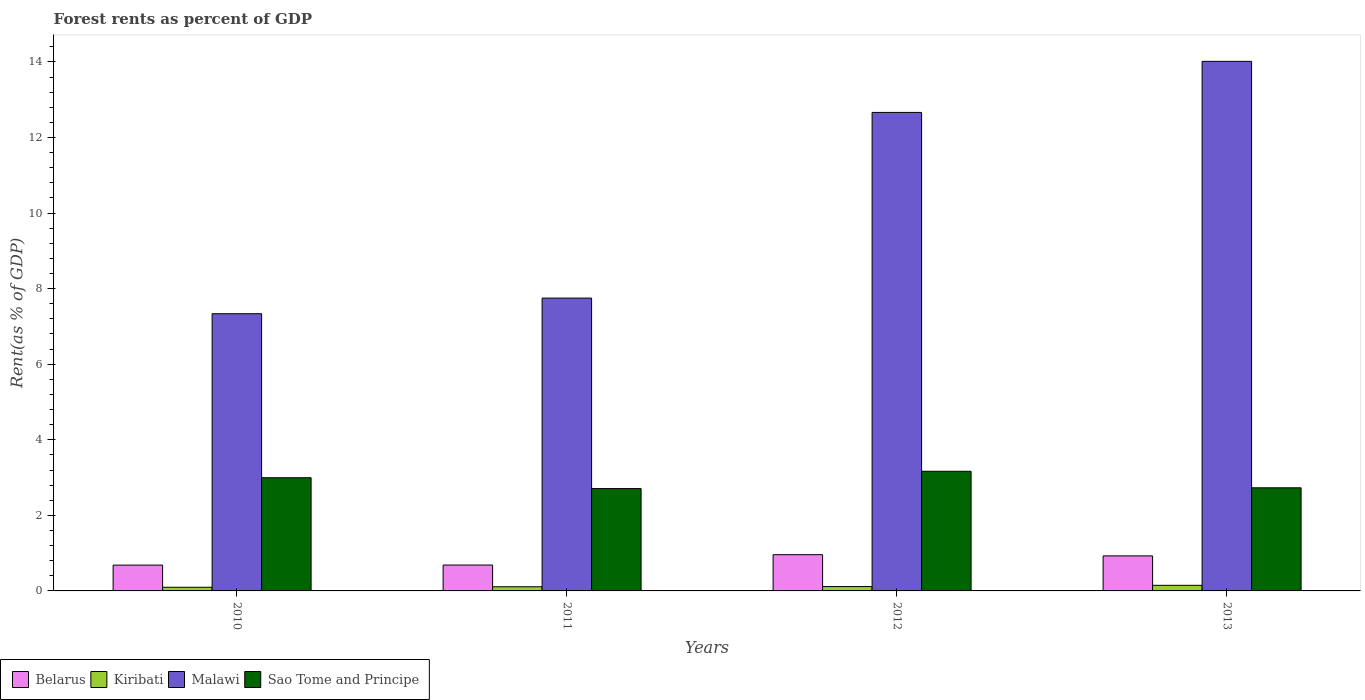How many different coloured bars are there?
Provide a succinct answer. 4. Are the number of bars per tick equal to the number of legend labels?
Provide a succinct answer. Yes. Are the number of bars on each tick of the X-axis equal?
Ensure brevity in your answer.  Yes. How many bars are there on the 1st tick from the left?
Keep it short and to the point. 4. How many bars are there on the 2nd tick from the right?
Offer a very short reply. 4. What is the label of the 3rd group of bars from the left?
Offer a terse response. 2012. What is the forest rent in Sao Tome and Principe in 2013?
Give a very brief answer. 2.73. Across all years, what is the maximum forest rent in Kiribati?
Your answer should be very brief. 0.15. Across all years, what is the minimum forest rent in Sao Tome and Principe?
Provide a short and direct response. 2.71. In which year was the forest rent in Malawi maximum?
Offer a very short reply. 2013. In which year was the forest rent in Malawi minimum?
Keep it short and to the point. 2010. What is the total forest rent in Kiribati in the graph?
Make the answer very short. 0.47. What is the difference between the forest rent in Kiribati in 2010 and that in 2011?
Provide a succinct answer. -0.01. What is the difference between the forest rent in Malawi in 2011 and the forest rent in Sao Tome and Principe in 2010?
Provide a succinct answer. 4.75. What is the average forest rent in Kiribati per year?
Keep it short and to the point. 0.12. In the year 2012, what is the difference between the forest rent in Belarus and forest rent in Kiribati?
Your answer should be very brief. 0.84. What is the ratio of the forest rent in Belarus in 2011 to that in 2013?
Give a very brief answer. 0.74. Is the forest rent in Malawi in 2010 less than that in 2013?
Ensure brevity in your answer.  Yes. What is the difference between the highest and the second highest forest rent in Kiribati?
Make the answer very short. 0.03. What is the difference between the highest and the lowest forest rent in Malawi?
Make the answer very short. 6.68. In how many years, is the forest rent in Malawi greater than the average forest rent in Malawi taken over all years?
Keep it short and to the point. 2. What does the 1st bar from the left in 2010 represents?
Ensure brevity in your answer.  Belarus. What does the 4th bar from the right in 2013 represents?
Offer a terse response. Belarus. Is it the case that in every year, the sum of the forest rent in Belarus and forest rent in Kiribati is greater than the forest rent in Malawi?
Your response must be concise. No. Does the graph contain grids?
Provide a short and direct response. No. How many legend labels are there?
Provide a succinct answer. 4. How are the legend labels stacked?
Give a very brief answer. Horizontal. What is the title of the graph?
Your answer should be compact. Forest rents as percent of GDP. What is the label or title of the Y-axis?
Provide a succinct answer. Rent(as % of GDP). What is the Rent(as % of GDP) of Belarus in 2010?
Make the answer very short. 0.68. What is the Rent(as % of GDP) in Kiribati in 2010?
Give a very brief answer. 0.1. What is the Rent(as % of GDP) in Malawi in 2010?
Ensure brevity in your answer.  7.34. What is the Rent(as % of GDP) of Sao Tome and Principe in 2010?
Your response must be concise. 3. What is the Rent(as % of GDP) in Belarus in 2011?
Make the answer very short. 0.69. What is the Rent(as % of GDP) in Kiribati in 2011?
Offer a terse response. 0.11. What is the Rent(as % of GDP) of Malawi in 2011?
Offer a terse response. 7.75. What is the Rent(as % of GDP) of Sao Tome and Principe in 2011?
Ensure brevity in your answer.  2.71. What is the Rent(as % of GDP) of Belarus in 2012?
Ensure brevity in your answer.  0.96. What is the Rent(as % of GDP) of Kiribati in 2012?
Give a very brief answer. 0.12. What is the Rent(as % of GDP) in Malawi in 2012?
Provide a succinct answer. 12.66. What is the Rent(as % of GDP) in Sao Tome and Principe in 2012?
Ensure brevity in your answer.  3.17. What is the Rent(as % of GDP) of Belarus in 2013?
Make the answer very short. 0.93. What is the Rent(as % of GDP) of Kiribati in 2013?
Offer a terse response. 0.15. What is the Rent(as % of GDP) of Malawi in 2013?
Offer a very short reply. 14.01. What is the Rent(as % of GDP) in Sao Tome and Principe in 2013?
Provide a succinct answer. 2.73. Across all years, what is the maximum Rent(as % of GDP) in Belarus?
Ensure brevity in your answer.  0.96. Across all years, what is the maximum Rent(as % of GDP) in Kiribati?
Offer a very short reply. 0.15. Across all years, what is the maximum Rent(as % of GDP) in Malawi?
Offer a very short reply. 14.01. Across all years, what is the maximum Rent(as % of GDP) of Sao Tome and Principe?
Keep it short and to the point. 3.17. Across all years, what is the minimum Rent(as % of GDP) in Belarus?
Make the answer very short. 0.68. Across all years, what is the minimum Rent(as % of GDP) of Kiribati?
Offer a very short reply. 0.1. Across all years, what is the minimum Rent(as % of GDP) of Malawi?
Give a very brief answer. 7.34. Across all years, what is the minimum Rent(as % of GDP) of Sao Tome and Principe?
Offer a very short reply. 2.71. What is the total Rent(as % of GDP) of Belarus in the graph?
Your answer should be very brief. 3.25. What is the total Rent(as % of GDP) of Kiribati in the graph?
Your answer should be compact. 0.47. What is the total Rent(as % of GDP) in Malawi in the graph?
Offer a very short reply. 41.76. What is the total Rent(as % of GDP) in Sao Tome and Principe in the graph?
Give a very brief answer. 11.6. What is the difference between the Rent(as % of GDP) in Belarus in 2010 and that in 2011?
Offer a very short reply. -0. What is the difference between the Rent(as % of GDP) in Kiribati in 2010 and that in 2011?
Offer a very short reply. -0.01. What is the difference between the Rent(as % of GDP) in Malawi in 2010 and that in 2011?
Make the answer very short. -0.41. What is the difference between the Rent(as % of GDP) in Sao Tome and Principe in 2010 and that in 2011?
Offer a very short reply. 0.29. What is the difference between the Rent(as % of GDP) in Belarus in 2010 and that in 2012?
Offer a terse response. -0.28. What is the difference between the Rent(as % of GDP) of Kiribati in 2010 and that in 2012?
Provide a succinct answer. -0.02. What is the difference between the Rent(as % of GDP) in Malawi in 2010 and that in 2012?
Your answer should be compact. -5.33. What is the difference between the Rent(as % of GDP) in Sao Tome and Principe in 2010 and that in 2012?
Give a very brief answer. -0.17. What is the difference between the Rent(as % of GDP) of Belarus in 2010 and that in 2013?
Ensure brevity in your answer.  -0.24. What is the difference between the Rent(as % of GDP) of Kiribati in 2010 and that in 2013?
Your answer should be very brief. -0.05. What is the difference between the Rent(as % of GDP) of Malawi in 2010 and that in 2013?
Your answer should be very brief. -6.68. What is the difference between the Rent(as % of GDP) in Sao Tome and Principe in 2010 and that in 2013?
Give a very brief answer. 0.27. What is the difference between the Rent(as % of GDP) of Belarus in 2011 and that in 2012?
Offer a terse response. -0.27. What is the difference between the Rent(as % of GDP) in Kiribati in 2011 and that in 2012?
Your answer should be very brief. -0.01. What is the difference between the Rent(as % of GDP) in Malawi in 2011 and that in 2012?
Your response must be concise. -4.91. What is the difference between the Rent(as % of GDP) of Sao Tome and Principe in 2011 and that in 2012?
Your answer should be compact. -0.46. What is the difference between the Rent(as % of GDP) in Belarus in 2011 and that in 2013?
Offer a terse response. -0.24. What is the difference between the Rent(as % of GDP) in Kiribati in 2011 and that in 2013?
Provide a succinct answer. -0.04. What is the difference between the Rent(as % of GDP) in Malawi in 2011 and that in 2013?
Keep it short and to the point. -6.26. What is the difference between the Rent(as % of GDP) in Sao Tome and Principe in 2011 and that in 2013?
Keep it short and to the point. -0.02. What is the difference between the Rent(as % of GDP) in Belarus in 2012 and that in 2013?
Offer a very short reply. 0.03. What is the difference between the Rent(as % of GDP) in Kiribati in 2012 and that in 2013?
Provide a short and direct response. -0.03. What is the difference between the Rent(as % of GDP) of Malawi in 2012 and that in 2013?
Keep it short and to the point. -1.35. What is the difference between the Rent(as % of GDP) in Sao Tome and Principe in 2012 and that in 2013?
Make the answer very short. 0.44. What is the difference between the Rent(as % of GDP) in Belarus in 2010 and the Rent(as % of GDP) in Kiribati in 2011?
Provide a succinct answer. 0.57. What is the difference between the Rent(as % of GDP) in Belarus in 2010 and the Rent(as % of GDP) in Malawi in 2011?
Make the answer very short. -7.07. What is the difference between the Rent(as % of GDP) in Belarus in 2010 and the Rent(as % of GDP) in Sao Tome and Principe in 2011?
Offer a very short reply. -2.03. What is the difference between the Rent(as % of GDP) of Kiribati in 2010 and the Rent(as % of GDP) of Malawi in 2011?
Give a very brief answer. -7.65. What is the difference between the Rent(as % of GDP) in Kiribati in 2010 and the Rent(as % of GDP) in Sao Tome and Principe in 2011?
Ensure brevity in your answer.  -2.61. What is the difference between the Rent(as % of GDP) in Malawi in 2010 and the Rent(as % of GDP) in Sao Tome and Principe in 2011?
Offer a terse response. 4.63. What is the difference between the Rent(as % of GDP) in Belarus in 2010 and the Rent(as % of GDP) in Kiribati in 2012?
Provide a succinct answer. 0.57. What is the difference between the Rent(as % of GDP) in Belarus in 2010 and the Rent(as % of GDP) in Malawi in 2012?
Give a very brief answer. -11.98. What is the difference between the Rent(as % of GDP) of Belarus in 2010 and the Rent(as % of GDP) of Sao Tome and Principe in 2012?
Make the answer very short. -2.48. What is the difference between the Rent(as % of GDP) of Kiribati in 2010 and the Rent(as % of GDP) of Malawi in 2012?
Keep it short and to the point. -12.57. What is the difference between the Rent(as % of GDP) of Kiribati in 2010 and the Rent(as % of GDP) of Sao Tome and Principe in 2012?
Your answer should be very brief. -3.07. What is the difference between the Rent(as % of GDP) in Malawi in 2010 and the Rent(as % of GDP) in Sao Tome and Principe in 2012?
Your answer should be very brief. 4.17. What is the difference between the Rent(as % of GDP) of Belarus in 2010 and the Rent(as % of GDP) of Kiribati in 2013?
Offer a very short reply. 0.54. What is the difference between the Rent(as % of GDP) in Belarus in 2010 and the Rent(as % of GDP) in Malawi in 2013?
Make the answer very short. -13.33. What is the difference between the Rent(as % of GDP) in Belarus in 2010 and the Rent(as % of GDP) in Sao Tome and Principe in 2013?
Provide a succinct answer. -2.05. What is the difference between the Rent(as % of GDP) of Kiribati in 2010 and the Rent(as % of GDP) of Malawi in 2013?
Make the answer very short. -13.92. What is the difference between the Rent(as % of GDP) of Kiribati in 2010 and the Rent(as % of GDP) of Sao Tome and Principe in 2013?
Your answer should be very brief. -2.63. What is the difference between the Rent(as % of GDP) of Malawi in 2010 and the Rent(as % of GDP) of Sao Tome and Principe in 2013?
Ensure brevity in your answer.  4.61. What is the difference between the Rent(as % of GDP) of Belarus in 2011 and the Rent(as % of GDP) of Kiribati in 2012?
Make the answer very short. 0.57. What is the difference between the Rent(as % of GDP) in Belarus in 2011 and the Rent(as % of GDP) in Malawi in 2012?
Your answer should be very brief. -11.98. What is the difference between the Rent(as % of GDP) of Belarus in 2011 and the Rent(as % of GDP) of Sao Tome and Principe in 2012?
Offer a very short reply. -2.48. What is the difference between the Rent(as % of GDP) of Kiribati in 2011 and the Rent(as % of GDP) of Malawi in 2012?
Keep it short and to the point. -12.55. What is the difference between the Rent(as % of GDP) of Kiribati in 2011 and the Rent(as % of GDP) of Sao Tome and Principe in 2012?
Offer a terse response. -3.06. What is the difference between the Rent(as % of GDP) in Malawi in 2011 and the Rent(as % of GDP) in Sao Tome and Principe in 2012?
Provide a short and direct response. 4.58. What is the difference between the Rent(as % of GDP) of Belarus in 2011 and the Rent(as % of GDP) of Kiribati in 2013?
Your answer should be very brief. 0.54. What is the difference between the Rent(as % of GDP) in Belarus in 2011 and the Rent(as % of GDP) in Malawi in 2013?
Provide a succinct answer. -13.33. What is the difference between the Rent(as % of GDP) in Belarus in 2011 and the Rent(as % of GDP) in Sao Tome and Principe in 2013?
Offer a very short reply. -2.04. What is the difference between the Rent(as % of GDP) in Kiribati in 2011 and the Rent(as % of GDP) in Malawi in 2013?
Keep it short and to the point. -13.9. What is the difference between the Rent(as % of GDP) of Kiribati in 2011 and the Rent(as % of GDP) of Sao Tome and Principe in 2013?
Offer a terse response. -2.62. What is the difference between the Rent(as % of GDP) in Malawi in 2011 and the Rent(as % of GDP) in Sao Tome and Principe in 2013?
Make the answer very short. 5.02. What is the difference between the Rent(as % of GDP) of Belarus in 2012 and the Rent(as % of GDP) of Kiribati in 2013?
Provide a short and direct response. 0.81. What is the difference between the Rent(as % of GDP) of Belarus in 2012 and the Rent(as % of GDP) of Malawi in 2013?
Make the answer very short. -13.06. What is the difference between the Rent(as % of GDP) of Belarus in 2012 and the Rent(as % of GDP) of Sao Tome and Principe in 2013?
Your answer should be very brief. -1.77. What is the difference between the Rent(as % of GDP) of Kiribati in 2012 and the Rent(as % of GDP) of Malawi in 2013?
Ensure brevity in your answer.  -13.9. What is the difference between the Rent(as % of GDP) in Kiribati in 2012 and the Rent(as % of GDP) in Sao Tome and Principe in 2013?
Give a very brief answer. -2.61. What is the difference between the Rent(as % of GDP) of Malawi in 2012 and the Rent(as % of GDP) of Sao Tome and Principe in 2013?
Offer a very short reply. 9.93. What is the average Rent(as % of GDP) in Belarus per year?
Your answer should be compact. 0.81. What is the average Rent(as % of GDP) in Kiribati per year?
Offer a terse response. 0.12. What is the average Rent(as % of GDP) of Malawi per year?
Your answer should be very brief. 10.44. What is the average Rent(as % of GDP) of Sao Tome and Principe per year?
Make the answer very short. 2.9. In the year 2010, what is the difference between the Rent(as % of GDP) of Belarus and Rent(as % of GDP) of Kiribati?
Your answer should be very brief. 0.59. In the year 2010, what is the difference between the Rent(as % of GDP) of Belarus and Rent(as % of GDP) of Malawi?
Ensure brevity in your answer.  -6.65. In the year 2010, what is the difference between the Rent(as % of GDP) of Belarus and Rent(as % of GDP) of Sao Tome and Principe?
Your response must be concise. -2.31. In the year 2010, what is the difference between the Rent(as % of GDP) in Kiribati and Rent(as % of GDP) in Malawi?
Your answer should be compact. -7.24. In the year 2010, what is the difference between the Rent(as % of GDP) of Kiribati and Rent(as % of GDP) of Sao Tome and Principe?
Your answer should be compact. -2.9. In the year 2010, what is the difference between the Rent(as % of GDP) of Malawi and Rent(as % of GDP) of Sao Tome and Principe?
Make the answer very short. 4.34. In the year 2011, what is the difference between the Rent(as % of GDP) of Belarus and Rent(as % of GDP) of Kiribati?
Keep it short and to the point. 0.57. In the year 2011, what is the difference between the Rent(as % of GDP) in Belarus and Rent(as % of GDP) in Malawi?
Make the answer very short. -7.06. In the year 2011, what is the difference between the Rent(as % of GDP) in Belarus and Rent(as % of GDP) in Sao Tome and Principe?
Your response must be concise. -2.02. In the year 2011, what is the difference between the Rent(as % of GDP) in Kiribati and Rent(as % of GDP) in Malawi?
Ensure brevity in your answer.  -7.64. In the year 2011, what is the difference between the Rent(as % of GDP) in Kiribati and Rent(as % of GDP) in Sao Tome and Principe?
Offer a very short reply. -2.6. In the year 2011, what is the difference between the Rent(as % of GDP) in Malawi and Rent(as % of GDP) in Sao Tome and Principe?
Make the answer very short. 5.04. In the year 2012, what is the difference between the Rent(as % of GDP) in Belarus and Rent(as % of GDP) in Kiribati?
Provide a succinct answer. 0.84. In the year 2012, what is the difference between the Rent(as % of GDP) of Belarus and Rent(as % of GDP) of Malawi?
Provide a succinct answer. -11.7. In the year 2012, what is the difference between the Rent(as % of GDP) in Belarus and Rent(as % of GDP) in Sao Tome and Principe?
Offer a very short reply. -2.21. In the year 2012, what is the difference between the Rent(as % of GDP) in Kiribati and Rent(as % of GDP) in Malawi?
Your answer should be compact. -12.55. In the year 2012, what is the difference between the Rent(as % of GDP) of Kiribati and Rent(as % of GDP) of Sao Tome and Principe?
Provide a succinct answer. -3.05. In the year 2012, what is the difference between the Rent(as % of GDP) of Malawi and Rent(as % of GDP) of Sao Tome and Principe?
Make the answer very short. 9.5. In the year 2013, what is the difference between the Rent(as % of GDP) in Belarus and Rent(as % of GDP) in Kiribati?
Your answer should be very brief. 0.78. In the year 2013, what is the difference between the Rent(as % of GDP) in Belarus and Rent(as % of GDP) in Malawi?
Your answer should be very brief. -13.09. In the year 2013, what is the difference between the Rent(as % of GDP) of Belarus and Rent(as % of GDP) of Sao Tome and Principe?
Ensure brevity in your answer.  -1.8. In the year 2013, what is the difference between the Rent(as % of GDP) of Kiribati and Rent(as % of GDP) of Malawi?
Offer a terse response. -13.87. In the year 2013, what is the difference between the Rent(as % of GDP) of Kiribati and Rent(as % of GDP) of Sao Tome and Principe?
Your response must be concise. -2.58. In the year 2013, what is the difference between the Rent(as % of GDP) in Malawi and Rent(as % of GDP) in Sao Tome and Principe?
Offer a very short reply. 11.29. What is the ratio of the Rent(as % of GDP) of Belarus in 2010 to that in 2011?
Your answer should be very brief. 1. What is the ratio of the Rent(as % of GDP) of Kiribati in 2010 to that in 2011?
Give a very brief answer. 0.88. What is the ratio of the Rent(as % of GDP) in Malawi in 2010 to that in 2011?
Offer a very short reply. 0.95. What is the ratio of the Rent(as % of GDP) of Sao Tome and Principe in 2010 to that in 2011?
Offer a very short reply. 1.11. What is the ratio of the Rent(as % of GDP) in Belarus in 2010 to that in 2012?
Ensure brevity in your answer.  0.71. What is the ratio of the Rent(as % of GDP) in Kiribati in 2010 to that in 2012?
Your answer should be compact. 0.84. What is the ratio of the Rent(as % of GDP) in Malawi in 2010 to that in 2012?
Give a very brief answer. 0.58. What is the ratio of the Rent(as % of GDP) in Sao Tome and Principe in 2010 to that in 2012?
Provide a succinct answer. 0.95. What is the ratio of the Rent(as % of GDP) in Belarus in 2010 to that in 2013?
Make the answer very short. 0.74. What is the ratio of the Rent(as % of GDP) of Kiribati in 2010 to that in 2013?
Give a very brief answer. 0.65. What is the ratio of the Rent(as % of GDP) of Malawi in 2010 to that in 2013?
Provide a short and direct response. 0.52. What is the ratio of the Rent(as % of GDP) of Sao Tome and Principe in 2010 to that in 2013?
Your response must be concise. 1.1. What is the ratio of the Rent(as % of GDP) of Belarus in 2011 to that in 2012?
Ensure brevity in your answer.  0.71. What is the ratio of the Rent(as % of GDP) of Kiribati in 2011 to that in 2012?
Your answer should be very brief. 0.95. What is the ratio of the Rent(as % of GDP) of Malawi in 2011 to that in 2012?
Provide a short and direct response. 0.61. What is the ratio of the Rent(as % of GDP) in Sao Tome and Principe in 2011 to that in 2012?
Your response must be concise. 0.86. What is the ratio of the Rent(as % of GDP) in Belarus in 2011 to that in 2013?
Ensure brevity in your answer.  0.74. What is the ratio of the Rent(as % of GDP) in Kiribati in 2011 to that in 2013?
Your response must be concise. 0.74. What is the ratio of the Rent(as % of GDP) of Malawi in 2011 to that in 2013?
Provide a short and direct response. 0.55. What is the ratio of the Rent(as % of GDP) of Sao Tome and Principe in 2011 to that in 2013?
Ensure brevity in your answer.  0.99. What is the ratio of the Rent(as % of GDP) of Belarus in 2012 to that in 2013?
Your answer should be very brief. 1.03. What is the ratio of the Rent(as % of GDP) of Kiribati in 2012 to that in 2013?
Provide a short and direct response. 0.78. What is the ratio of the Rent(as % of GDP) of Malawi in 2012 to that in 2013?
Give a very brief answer. 0.9. What is the ratio of the Rent(as % of GDP) of Sao Tome and Principe in 2012 to that in 2013?
Give a very brief answer. 1.16. What is the difference between the highest and the second highest Rent(as % of GDP) in Belarus?
Offer a terse response. 0.03. What is the difference between the highest and the second highest Rent(as % of GDP) in Kiribati?
Offer a terse response. 0.03. What is the difference between the highest and the second highest Rent(as % of GDP) in Malawi?
Your answer should be compact. 1.35. What is the difference between the highest and the second highest Rent(as % of GDP) of Sao Tome and Principe?
Ensure brevity in your answer.  0.17. What is the difference between the highest and the lowest Rent(as % of GDP) of Belarus?
Offer a terse response. 0.28. What is the difference between the highest and the lowest Rent(as % of GDP) of Kiribati?
Ensure brevity in your answer.  0.05. What is the difference between the highest and the lowest Rent(as % of GDP) in Malawi?
Give a very brief answer. 6.68. What is the difference between the highest and the lowest Rent(as % of GDP) of Sao Tome and Principe?
Your answer should be compact. 0.46. 